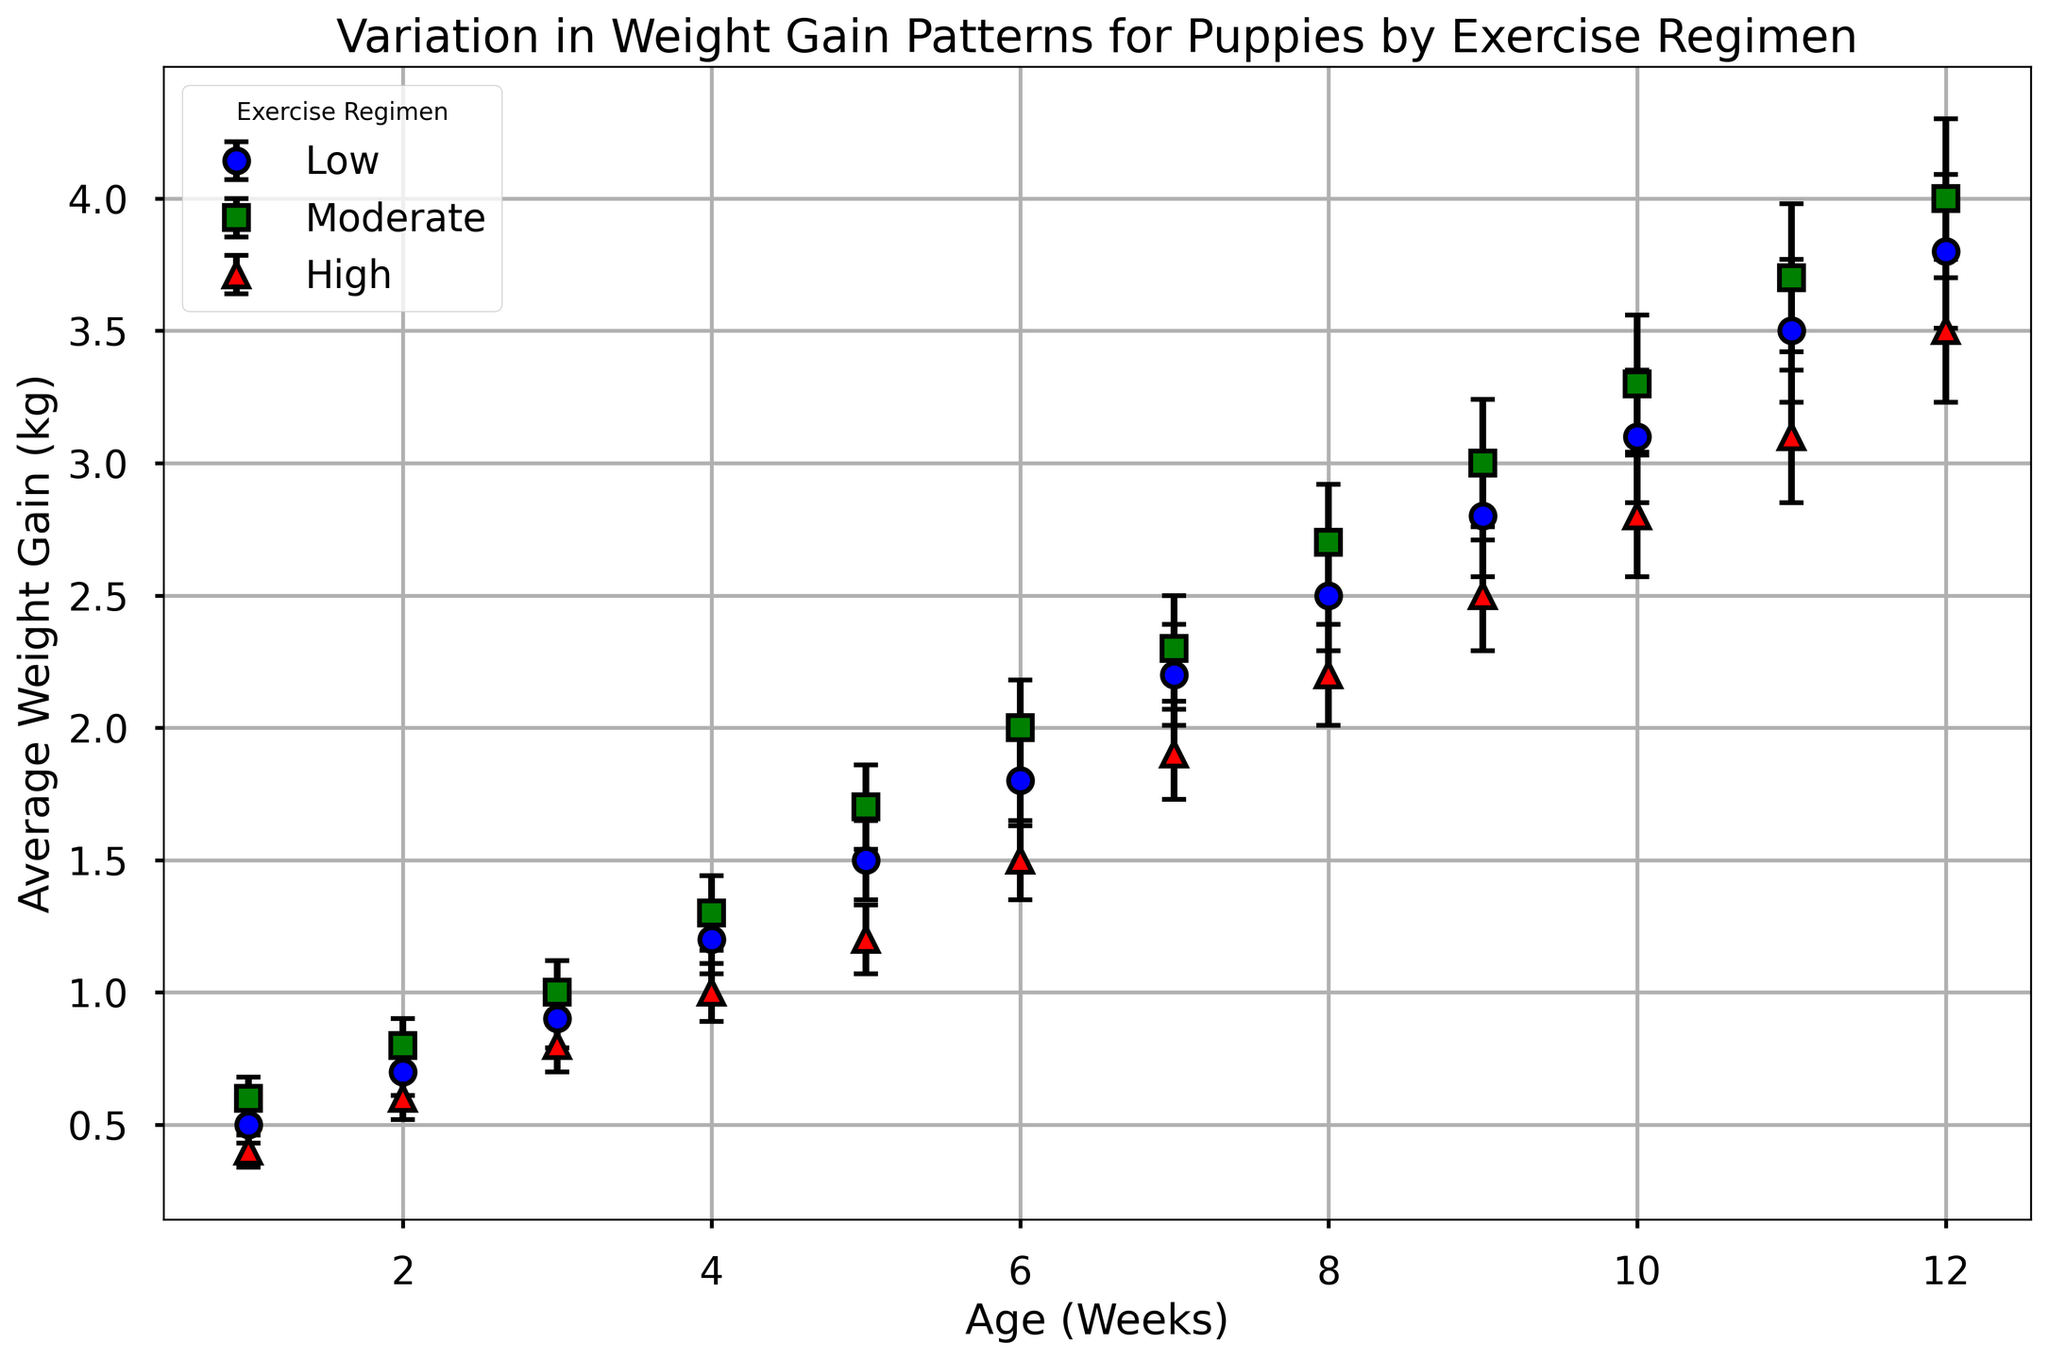Which exercise regimen exhibits the highest average weight gain at Week 4? Look at Week 4 on the x-axis and compare the average weight gains for each regimen (Low, Moderate, High). The Moderate regimen has the highest average weight gain.
Answer: Moderate How does the weight gain for puppies on the High exercise regimen at Week 6 compare to those on the Moderate regimen at the same week? Check Week 6 on the x-axis and compare the average weight gain for High and Moderate exercise regimens. The High regimen has a lower average weight gain compared to the Moderate regimen.
Answer: Lower What is the difference in average weight gain between the Low and High exercise regimens at Week 10? At Week 10, the average weight gain for Low is 3.1 kg and for High is 2.8 kg. The difference is 3.1 kg - 2.8 kg = 0.3 kg.
Answer: 0.3 kg At which week do puppies on the Low exercise regimen first exceed an average weight gain of 2 kg? Check the Low regimen average weight gains along the y-axis and identify the week when it first exceeds 2 kg. It happens at Week 7.
Answer: Week 7 Which exercise regimen shows the least variation (smallest standard deviation) in weight gain across all weeks? Compare the standard deviations for all exercise regimens across all weeks. The High regimen generally shows smaller standard deviations compared to Low and Moderate regimens.
Answer: High What's the average weight gain difference between Week 3 and Week 5 for puppies on the Moderate exercise regimen? For the Moderate regimen, the average weight gain at Week 5 is 1.7 kg and at Week 3 is 1.0 kg. The difference is 1.7 kg - 1.0 kg = 0.7 kg.
Answer: 0.7 kg Compare the visual markers used for each exercise regimen and describe their differences. The visual markers are different shapes and colors: Low regimen is marked with blue circles, Moderate regimen with green squares, and High regimen with red triangles.
Answer: Blue circles, Green squares, Red triangles What is the overall trend in weight gain for the Low exercise regimen from Week 1 to Week 12? Observe the Low regimen's average weight gain values from Week 1 to Week 12. The trend shows a steady increase in average weight gain over time.
Answer: Steady increase How much higher is the average weight gain for puppies on the Moderate regimen compared to the High regimen at Week 9? In Week 9, the average weight gain for Moderate regimen is 3.0 kg and for High is 2.5 kg. The difference is 3.0 kg - 2.5 kg = 0.5 kg.
Answer: 0.5 kg Between which two consecutive weeks does the High exercise regimen see the largest increase in average weight gain? Check the High regimen's average weight gain values week by week. The largest increase is between Week 10 (2.8 kg) and Week 11 (3.1 kg), which is 3.1 kg - 2.8 kg = 0.3 kg.
Answer: Weeks 10 and 11 